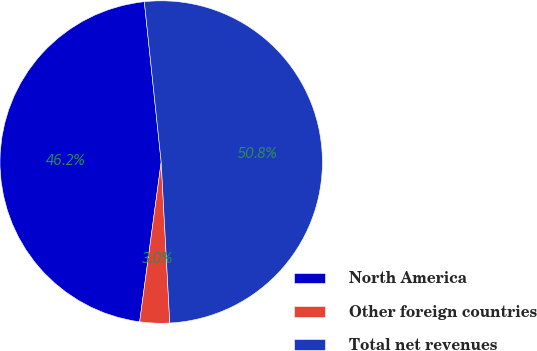<chart> <loc_0><loc_0><loc_500><loc_500><pie_chart><fcel>North America<fcel>Other foreign countries<fcel>Total net revenues<nl><fcel>46.2%<fcel>2.98%<fcel>50.82%<nl></chart> 